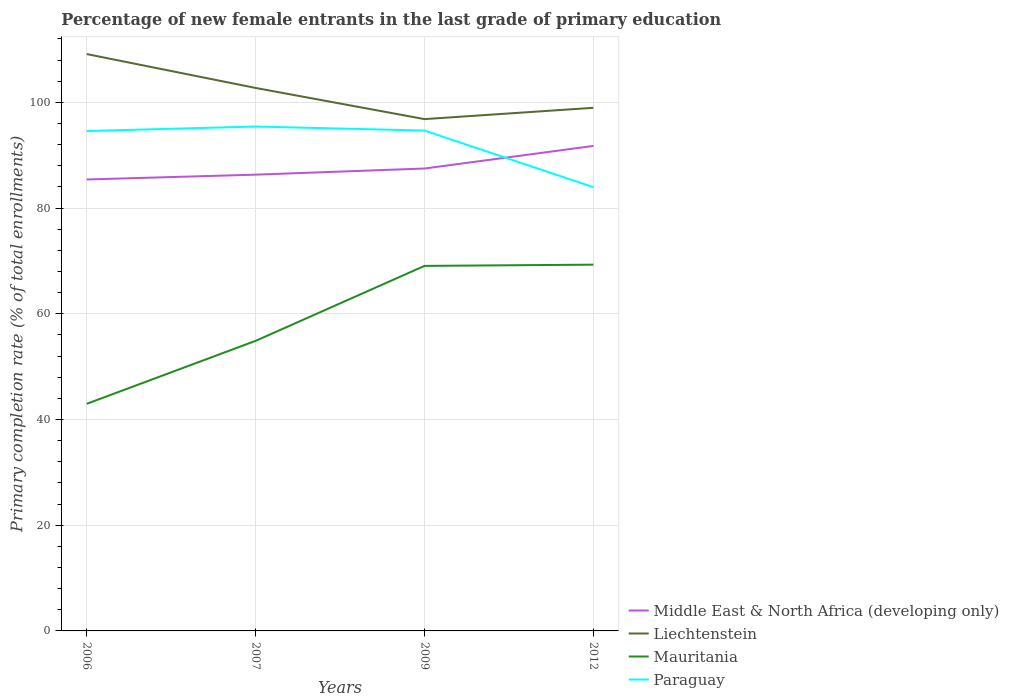How many different coloured lines are there?
Make the answer very short. 4. Does the line corresponding to Liechtenstein intersect with the line corresponding to Middle East & North Africa (developing only)?
Offer a terse response. No. Across all years, what is the maximum percentage of new female entrants in Mauritania?
Your answer should be compact. 42.97. In which year was the percentage of new female entrants in Mauritania maximum?
Give a very brief answer. 2006. What is the total percentage of new female entrants in Liechtenstein in the graph?
Offer a very short reply. -2.14. What is the difference between the highest and the second highest percentage of new female entrants in Mauritania?
Your answer should be very brief. 26.33. Is the percentage of new female entrants in Liechtenstein strictly greater than the percentage of new female entrants in Paraguay over the years?
Provide a short and direct response. No. How many years are there in the graph?
Offer a very short reply. 4. Are the values on the major ticks of Y-axis written in scientific E-notation?
Your response must be concise. No. What is the title of the graph?
Ensure brevity in your answer.  Percentage of new female entrants in the last grade of primary education. Does "North America" appear as one of the legend labels in the graph?
Make the answer very short. No. What is the label or title of the Y-axis?
Give a very brief answer. Primary completion rate (% of total enrollments). What is the Primary completion rate (% of total enrollments) in Middle East & North Africa (developing only) in 2006?
Give a very brief answer. 85.41. What is the Primary completion rate (% of total enrollments) in Liechtenstein in 2006?
Your answer should be very brief. 109.14. What is the Primary completion rate (% of total enrollments) of Mauritania in 2006?
Offer a very short reply. 42.97. What is the Primary completion rate (% of total enrollments) of Paraguay in 2006?
Make the answer very short. 94.58. What is the Primary completion rate (% of total enrollments) of Middle East & North Africa (developing only) in 2007?
Your answer should be compact. 86.32. What is the Primary completion rate (% of total enrollments) of Liechtenstein in 2007?
Make the answer very short. 102.73. What is the Primary completion rate (% of total enrollments) of Mauritania in 2007?
Your response must be concise. 54.88. What is the Primary completion rate (% of total enrollments) of Paraguay in 2007?
Offer a terse response. 95.43. What is the Primary completion rate (% of total enrollments) of Middle East & North Africa (developing only) in 2009?
Your answer should be very brief. 87.49. What is the Primary completion rate (% of total enrollments) in Liechtenstein in 2009?
Offer a very short reply. 96.83. What is the Primary completion rate (% of total enrollments) of Mauritania in 2009?
Your response must be concise. 69.06. What is the Primary completion rate (% of total enrollments) in Paraguay in 2009?
Keep it short and to the point. 94.67. What is the Primary completion rate (% of total enrollments) of Middle East & North Africa (developing only) in 2012?
Offer a very short reply. 91.76. What is the Primary completion rate (% of total enrollments) of Liechtenstein in 2012?
Provide a succinct answer. 98.97. What is the Primary completion rate (% of total enrollments) of Mauritania in 2012?
Keep it short and to the point. 69.3. What is the Primary completion rate (% of total enrollments) of Paraguay in 2012?
Provide a short and direct response. 83.96. Across all years, what is the maximum Primary completion rate (% of total enrollments) of Middle East & North Africa (developing only)?
Provide a short and direct response. 91.76. Across all years, what is the maximum Primary completion rate (% of total enrollments) in Liechtenstein?
Provide a short and direct response. 109.14. Across all years, what is the maximum Primary completion rate (% of total enrollments) in Mauritania?
Your response must be concise. 69.3. Across all years, what is the maximum Primary completion rate (% of total enrollments) of Paraguay?
Offer a very short reply. 95.43. Across all years, what is the minimum Primary completion rate (% of total enrollments) in Middle East & North Africa (developing only)?
Provide a succinct answer. 85.41. Across all years, what is the minimum Primary completion rate (% of total enrollments) in Liechtenstein?
Your answer should be compact. 96.83. Across all years, what is the minimum Primary completion rate (% of total enrollments) of Mauritania?
Offer a terse response. 42.97. Across all years, what is the minimum Primary completion rate (% of total enrollments) of Paraguay?
Offer a very short reply. 83.96. What is the total Primary completion rate (% of total enrollments) of Middle East & North Africa (developing only) in the graph?
Give a very brief answer. 350.98. What is the total Primary completion rate (% of total enrollments) in Liechtenstein in the graph?
Make the answer very short. 407.67. What is the total Primary completion rate (% of total enrollments) of Mauritania in the graph?
Provide a succinct answer. 236.21. What is the total Primary completion rate (% of total enrollments) of Paraguay in the graph?
Your answer should be very brief. 368.63. What is the difference between the Primary completion rate (% of total enrollments) of Middle East & North Africa (developing only) in 2006 and that in 2007?
Offer a very short reply. -0.91. What is the difference between the Primary completion rate (% of total enrollments) in Liechtenstein in 2006 and that in 2007?
Give a very brief answer. 6.41. What is the difference between the Primary completion rate (% of total enrollments) in Mauritania in 2006 and that in 2007?
Offer a very short reply. -11.91. What is the difference between the Primary completion rate (% of total enrollments) of Paraguay in 2006 and that in 2007?
Your answer should be very brief. -0.85. What is the difference between the Primary completion rate (% of total enrollments) of Middle East & North Africa (developing only) in 2006 and that in 2009?
Offer a terse response. -2.07. What is the difference between the Primary completion rate (% of total enrollments) of Liechtenstein in 2006 and that in 2009?
Your answer should be very brief. 12.31. What is the difference between the Primary completion rate (% of total enrollments) in Mauritania in 2006 and that in 2009?
Ensure brevity in your answer.  -26.09. What is the difference between the Primary completion rate (% of total enrollments) in Paraguay in 2006 and that in 2009?
Provide a short and direct response. -0.09. What is the difference between the Primary completion rate (% of total enrollments) of Middle East & North Africa (developing only) in 2006 and that in 2012?
Give a very brief answer. -6.35. What is the difference between the Primary completion rate (% of total enrollments) in Liechtenstein in 2006 and that in 2012?
Your answer should be very brief. 10.17. What is the difference between the Primary completion rate (% of total enrollments) in Mauritania in 2006 and that in 2012?
Your answer should be compact. -26.33. What is the difference between the Primary completion rate (% of total enrollments) of Paraguay in 2006 and that in 2012?
Make the answer very short. 10.62. What is the difference between the Primary completion rate (% of total enrollments) in Middle East & North Africa (developing only) in 2007 and that in 2009?
Provide a succinct answer. -1.16. What is the difference between the Primary completion rate (% of total enrollments) in Liechtenstein in 2007 and that in 2009?
Your answer should be very brief. 5.89. What is the difference between the Primary completion rate (% of total enrollments) of Mauritania in 2007 and that in 2009?
Offer a very short reply. -14.18. What is the difference between the Primary completion rate (% of total enrollments) of Paraguay in 2007 and that in 2009?
Your response must be concise. 0.76. What is the difference between the Primary completion rate (% of total enrollments) in Middle East & North Africa (developing only) in 2007 and that in 2012?
Offer a very short reply. -5.43. What is the difference between the Primary completion rate (% of total enrollments) of Liechtenstein in 2007 and that in 2012?
Offer a terse response. 3.75. What is the difference between the Primary completion rate (% of total enrollments) of Mauritania in 2007 and that in 2012?
Give a very brief answer. -14.42. What is the difference between the Primary completion rate (% of total enrollments) in Paraguay in 2007 and that in 2012?
Make the answer very short. 11.47. What is the difference between the Primary completion rate (% of total enrollments) in Middle East & North Africa (developing only) in 2009 and that in 2012?
Provide a succinct answer. -4.27. What is the difference between the Primary completion rate (% of total enrollments) in Liechtenstein in 2009 and that in 2012?
Offer a terse response. -2.14. What is the difference between the Primary completion rate (% of total enrollments) in Mauritania in 2009 and that in 2012?
Provide a short and direct response. -0.23. What is the difference between the Primary completion rate (% of total enrollments) in Paraguay in 2009 and that in 2012?
Give a very brief answer. 10.71. What is the difference between the Primary completion rate (% of total enrollments) of Middle East & North Africa (developing only) in 2006 and the Primary completion rate (% of total enrollments) of Liechtenstein in 2007?
Keep it short and to the point. -17.31. What is the difference between the Primary completion rate (% of total enrollments) of Middle East & North Africa (developing only) in 2006 and the Primary completion rate (% of total enrollments) of Mauritania in 2007?
Ensure brevity in your answer.  30.53. What is the difference between the Primary completion rate (% of total enrollments) of Middle East & North Africa (developing only) in 2006 and the Primary completion rate (% of total enrollments) of Paraguay in 2007?
Ensure brevity in your answer.  -10.02. What is the difference between the Primary completion rate (% of total enrollments) of Liechtenstein in 2006 and the Primary completion rate (% of total enrollments) of Mauritania in 2007?
Provide a short and direct response. 54.26. What is the difference between the Primary completion rate (% of total enrollments) in Liechtenstein in 2006 and the Primary completion rate (% of total enrollments) in Paraguay in 2007?
Your answer should be compact. 13.71. What is the difference between the Primary completion rate (% of total enrollments) of Mauritania in 2006 and the Primary completion rate (% of total enrollments) of Paraguay in 2007?
Your answer should be compact. -52.46. What is the difference between the Primary completion rate (% of total enrollments) of Middle East & North Africa (developing only) in 2006 and the Primary completion rate (% of total enrollments) of Liechtenstein in 2009?
Your response must be concise. -11.42. What is the difference between the Primary completion rate (% of total enrollments) of Middle East & North Africa (developing only) in 2006 and the Primary completion rate (% of total enrollments) of Mauritania in 2009?
Your answer should be compact. 16.35. What is the difference between the Primary completion rate (% of total enrollments) in Middle East & North Africa (developing only) in 2006 and the Primary completion rate (% of total enrollments) in Paraguay in 2009?
Your response must be concise. -9.25. What is the difference between the Primary completion rate (% of total enrollments) in Liechtenstein in 2006 and the Primary completion rate (% of total enrollments) in Mauritania in 2009?
Keep it short and to the point. 40.08. What is the difference between the Primary completion rate (% of total enrollments) in Liechtenstein in 2006 and the Primary completion rate (% of total enrollments) in Paraguay in 2009?
Offer a very short reply. 14.47. What is the difference between the Primary completion rate (% of total enrollments) of Mauritania in 2006 and the Primary completion rate (% of total enrollments) of Paraguay in 2009?
Offer a very short reply. -51.7. What is the difference between the Primary completion rate (% of total enrollments) of Middle East & North Africa (developing only) in 2006 and the Primary completion rate (% of total enrollments) of Liechtenstein in 2012?
Ensure brevity in your answer.  -13.56. What is the difference between the Primary completion rate (% of total enrollments) in Middle East & North Africa (developing only) in 2006 and the Primary completion rate (% of total enrollments) in Mauritania in 2012?
Make the answer very short. 16.12. What is the difference between the Primary completion rate (% of total enrollments) of Middle East & North Africa (developing only) in 2006 and the Primary completion rate (% of total enrollments) of Paraguay in 2012?
Make the answer very short. 1.45. What is the difference between the Primary completion rate (% of total enrollments) in Liechtenstein in 2006 and the Primary completion rate (% of total enrollments) in Mauritania in 2012?
Provide a short and direct response. 39.84. What is the difference between the Primary completion rate (% of total enrollments) in Liechtenstein in 2006 and the Primary completion rate (% of total enrollments) in Paraguay in 2012?
Give a very brief answer. 25.18. What is the difference between the Primary completion rate (% of total enrollments) in Mauritania in 2006 and the Primary completion rate (% of total enrollments) in Paraguay in 2012?
Offer a terse response. -40.99. What is the difference between the Primary completion rate (% of total enrollments) in Middle East & North Africa (developing only) in 2007 and the Primary completion rate (% of total enrollments) in Liechtenstein in 2009?
Offer a very short reply. -10.51. What is the difference between the Primary completion rate (% of total enrollments) of Middle East & North Africa (developing only) in 2007 and the Primary completion rate (% of total enrollments) of Mauritania in 2009?
Your response must be concise. 17.26. What is the difference between the Primary completion rate (% of total enrollments) of Middle East & North Africa (developing only) in 2007 and the Primary completion rate (% of total enrollments) of Paraguay in 2009?
Your answer should be very brief. -8.34. What is the difference between the Primary completion rate (% of total enrollments) of Liechtenstein in 2007 and the Primary completion rate (% of total enrollments) of Mauritania in 2009?
Give a very brief answer. 33.66. What is the difference between the Primary completion rate (% of total enrollments) in Liechtenstein in 2007 and the Primary completion rate (% of total enrollments) in Paraguay in 2009?
Offer a very short reply. 8.06. What is the difference between the Primary completion rate (% of total enrollments) in Mauritania in 2007 and the Primary completion rate (% of total enrollments) in Paraguay in 2009?
Your answer should be compact. -39.79. What is the difference between the Primary completion rate (% of total enrollments) in Middle East & North Africa (developing only) in 2007 and the Primary completion rate (% of total enrollments) in Liechtenstein in 2012?
Provide a succinct answer. -12.65. What is the difference between the Primary completion rate (% of total enrollments) of Middle East & North Africa (developing only) in 2007 and the Primary completion rate (% of total enrollments) of Mauritania in 2012?
Provide a succinct answer. 17.03. What is the difference between the Primary completion rate (% of total enrollments) of Middle East & North Africa (developing only) in 2007 and the Primary completion rate (% of total enrollments) of Paraguay in 2012?
Make the answer very short. 2.37. What is the difference between the Primary completion rate (% of total enrollments) of Liechtenstein in 2007 and the Primary completion rate (% of total enrollments) of Mauritania in 2012?
Provide a short and direct response. 33.43. What is the difference between the Primary completion rate (% of total enrollments) in Liechtenstein in 2007 and the Primary completion rate (% of total enrollments) in Paraguay in 2012?
Your answer should be compact. 18.77. What is the difference between the Primary completion rate (% of total enrollments) of Mauritania in 2007 and the Primary completion rate (% of total enrollments) of Paraguay in 2012?
Ensure brevity in your answer.  -29.08. What is the difference between the Primary completion rate (% of total enrollments) of Middle East & North Africa (developing only) in 2009 and the Primary completion rate (% of total enrollments) of Liechtenstein in 2012?
Give a very brief answer. -11.49. What is the difference between the Primary completion rate (% of total enrollments) in Middle East & North Africa (developing only) in 2009 and the Primary completion rate (% of total enrollments) in Mauritania in 2012?
Provide a succinct answer. 18.19. What is the difference between the Primary completion rate (% of total enrollments) of Middle East & North Africa (developing only) in 2009 and the Primary completion rate (% of total enrollments) of Paraguay in 2012?
Keep it short and to the point. 3.53. What is the difference between the Primary completion rate (% of total enrollments) in Liechtenstein in 2009 and the Primary completion rate (% of total enrollments) in Mauritania in 2012?
Make the answer very short. 27.54. What is the difference between the Primary completion rate (% of total enrollments) in Liechtenstein in 2009 and the Primary completion rate (% of total enrollments) in Paraguay in 2012?
Provide a short and direct response. 12.87. What is the difference between the Primary completion rate (% of total enrollments) of Mauritania in 2009 and the Primary completion rate (% of total enrollments) of Paraguay in 2012?
Keep it short and to the point. -14.9. What is the average Primary completion rate (% of total enrollments) in Middle East & North Africa (developing only) per year?
Provide a succinct answer. 87.75. What is the average Primary completion rate (% of total enrollments) in Liechtenstein per year?
Your answer should be very brief. 101.92. What is the average Primary completion rate (% of total enrollments) of Mauritania per year?
Make the answer very short. 59.05. What is the average Primary completion rate (% of total enrollments) of Paraguay per year?
Provide a succinct answer. 92.16. In the year 2006, what is the difference between the Primary completion rate (% of total enrollments) of Middle East & North Africa (developing only) and Primary completion rate (% of total enrollments) of Liechtenstein?
Offer a very short reply. -23.73. In the year 2006, what is the difference between the Primary completion rate (% of total enrollments) of Middle East & North Africa (developing only) and Primary completion rate (% of total enrollments) of Mauritania?
Keep it short and to the point. 42.44. In the year 2006, what is the difference between the Primary completion rate (% of total enrollments) in Middle East & North Africa (developing only) and Primary completion rate (% of total enrollments) in Paraguay?
Ensure brevity in your answer.  -9.16. In the year 2006, what is the difference between the Primary completion rate (% of total enrollments) of Liechtenstein and Primary completion rate (% of total enrollments) of Mauritania?
Your answer should be very brief. 66.17. In the year 2006, what is the difference between the Primary completion rate (% of total enrollments) in Liechtenstein and Primary completion rate (% of total enrollments) in Paraguay?
Your answer should be very brief. 14.56. In the year 2006, what is the difference between the Primary completion rate (% of total enrollments) of Mauritania and Primary completion rate (% of total enrollments) of Paraguay?
Offer a very short reply. -51.61. In the year 2007, what is the difference between the Primary completion rate (% of total enrollments) in Middle East & North Africa (developing only) and Primary completion rate (% of total enrollments) in Liechtenstein?
Keep it short and to the point. -16.4. In the year 2007, what is the difference between the Primary completion rate (% of total enrollments) of Middle East & North Africa (developing only) and Primary completion rate (% of total enrollments) of Mauritania?
Ensure brevity in your answer.  31.45. In the year 2007, what is the difference between the Primary completion rate (% of total enrollments) of Middle East & North Africa (developing only) and Primary completion rate (% of total enrollments) of Paraguay?
Your response must be concise. -9.11. In the year 2007, what is the difference between the Primary completion rate (% of total enrollments) of Liechtenstein and Primary completion rate (% of total enrollments) of Mauritania?
Offer a terse response. 47.85. In the year 2007, what is the difference between the Primary completion rate (% of total enrollments) in Liechtenstein and Primary completion rate (% of total enrollments) in Paraguay?
Keep it short and to the point. 7.3. In the year 2007, what is the difference between the Primary completion rate (% of total enrollments) in Mauritania and Primary completion rate (% of total enrollments) in Paraguay?
Your answer should be very brief. -40.55. In the year 2009, what is the difference between the Primary completion rate (% of total enrollments) in Middle East & North Africa (developing only) and Primary completion rate (% of total enrollments) in Liechtenstein?
Offer a terse response. -9.35. In the year 2009, what is the difference between the Primary completion rate (% of total enrollments) of Middle East & North Africa (developing only) and Primary completion rate (% of total enrollments) of Mauritania?
Offer a terse response. 18.42. In the year 2009, what is the difference between the Primary completion rate (% of total enrollments) of Middle East & North Africa (developing only) and Primary completion rate (% of total enrollments) of Paraguay?
Your answer should be very brief. -7.18. In the year 2009, what is the difference between the Primary completion rate (% of total enrollments) in Liechtenstein and Primary completion rate (% of total enrollments) in Mauritania?
Offer a very short reply. 27.77. In the year 2009, what is the difference between the Primary completion rate (% of total enrollments) in Liechtenstein and Primary completion rate (% of total enrollments) in Paraguay?
Make the answer very short. 2.17. In the year 2009, what is the difference between the Primary completion rate (% of total enrollments) in Mauritania and Primary completion rate (% of total enrollments) in Paraguay?
Provide a short and direct response. -25.6. In the year 2012, what is the difference between the Primary completion rate (% of total enrollments) of Middle East & North Africa (developing only) and Primary completion rate (% of total enrollments) of Liechtenstein?
Give a very brief answer. -7.22. In the year 2012, what is the difference between the Primary completion rate (% of total enrollments) in Middle East & North Africa (developing only) and Primary completion rate (% of total enrollments) in Mauritania?
Your answer should be very brief. 22.46. In the year 2012, what is the difference between the Primary completion rate (% of total enrollments) of Middle East & North Africa (developing only) and Primary completion rate (% of total enrollments) of Paraguay?
Ensure brevity in your answer.  7.8. In the year 2012, what is the difference between the Primary completion rate (% of total enrollments) of Liechtenstein and Primary completion rate (% of total enrollments) of Mauritania?
Your response must be concise. 29.68. In the year 2012, what is the difference between the Primary completion rate (% of total enrollments) in Liechtenstein and Primary completion rate (% of total enrollments) in Paraguay?
Offer a terse response. 15.02. In the year 2012, what is the difference between the Primary completion rate (% of total enrollments) in Mauritania and Primary completion rate (% of total enrollments) in Paraguay?
Offer a very short reply. -14.66. What is the ratio of the Primary completion rate (% of total enrollments) in Liechtenstein in 2006 to that in 2007?
Give a very brief answer. 1.06. What is the ratio of the Primary completion rate (% of total enrollments) of Mauritania in 2006 to that in 2007?
Ensure brevity in your answer.  0.78. What is the ratio of the Primary completion rate (% of total enrollments) of Paraguay in 2006 to that in 2007?
Provide a succinct answer. 0.99. What is the ratio of the Primary completion rate (% of total enrollments) in Middle East & North Africa (developing only) in 2006 to that in 2009?
Keep it short and to the point. 0.98. What is the ratio of the Primary completion rate (% of total enrollments) in Liechtenstein in 2006 to that in 2009?
Give a very brief answer. 1.13. What is the ratio of the Primary completion rate (% of total enrollments) of Mauritania in 2006 to that in 2009?
Your answer should be compact. 0.62. What is the ratio of the Primary completion rate (% of total enrollments) of Middle East & North Africa (developing only) in 2006 to that in 2012?
Offer a very short reply. 0.93. What is the ratio of the Primary completion rate (% of total enrollments) in Liechtenstein in 2006 to that in 2012?
Offer a terse response. 1.1. What is the ratio of the Primary completion rate (% of total enrollments) in Mauritania in 2006 to that in 2012?
Make the answer very short. 0.62. What is the ratio of the Primary completion rate (% of total enrollments) in Paraguay in 2006 to that in 2012?
Make the answer very short. 1.13. What is the ratio of the Primary completion rate (% of total enrollments) in Middle East & North Africa (developing only) in 2007 to that in 2009?
Provide a succinct answer. 0.99. What is the ratio of the Primary completion rate (% of total enrollments) in Liechtenstein in 2007 to that in 2009?
Provide a short and direct response. 1.06. What is the ratio of the Primary completion rate (% of total enrollments) in Mauritania in 2007 to that in 2009?
Offer a very short reply. 0.79. What is the ratio of the Primary completion rate (% of total enrollments) in Middle East & North Africa (developing only) in 2007 to that in 2012?
Offer a terse response. 0.94. What is the ratio of the Primary completion rate (% of total enrollments) of Liechtenstein in 2007 to that in 2012?
Give a very brief answer. 1.04. What is the ratio of the Primary completion rate (% of total enrollments) of Mauritania in 2007 to that in 2012?
Give a very brief answer. 0.79. What is the ratio of the Primary completion rate (% of total enrollments) of Paraguay in 2007 to that in 2012?
Your answer should be very brief. 1.14. What is the ratio of the Primary completion rate (% of total enrollments) of Middle East & North Africa (developing only) in 2009 to that in 2012?
Your response must be concise. 0.95. What is the ratio of the Primary completion rate (% of total enrollments) in Liechtenstein in 2009 to that in 2012?
Provide a short and direct response. 0.98. What is the ratio of the Primary completion rate (% of total enrollments) in Paraguay in 2009 to that in 2012?
Give a very brief answer. 1.13. What is the difference between the highest and the second highest Primary completion rate (% of total enrollments) in Middle East & North Africa (developing only)?
Offer a terse response. 4.27. What is the difference between the highest and the second highest Primary completion rate (% of total enrollments) of Liechtenstein?
Your answer should be very brief. 6.41. What is the difference between the highest and the second highest Primary completion rate (% of total enrollments) in Mauritania?
Provide a short and direct response. 0.23. What is the difference between the highest and the second highest Primary completion rate (% of total enrollments) of Paraguay?
Keep it short and to the point. 0.76. What is the difference between the highest and the lowest Primary completion rate (% of total enrollments) in Middle East & North Africa (developing only)?
Your answer should be very brief. 6.35. What is the difference between the highest and the lowest Primary completion rate (% of total enrollments) of Liechtenstein?
Offer a very short reply. 12.31. What is the difference between the highest and the lowest Primary completion rate (% of total enrollments) in Mauritania?
Provide a succinct answer. 26.33. What is the difference between the highest and the lowest Primary completion rate (% of total enrollments) in Paraguay?
Keep it short and to the point. 11.47. 